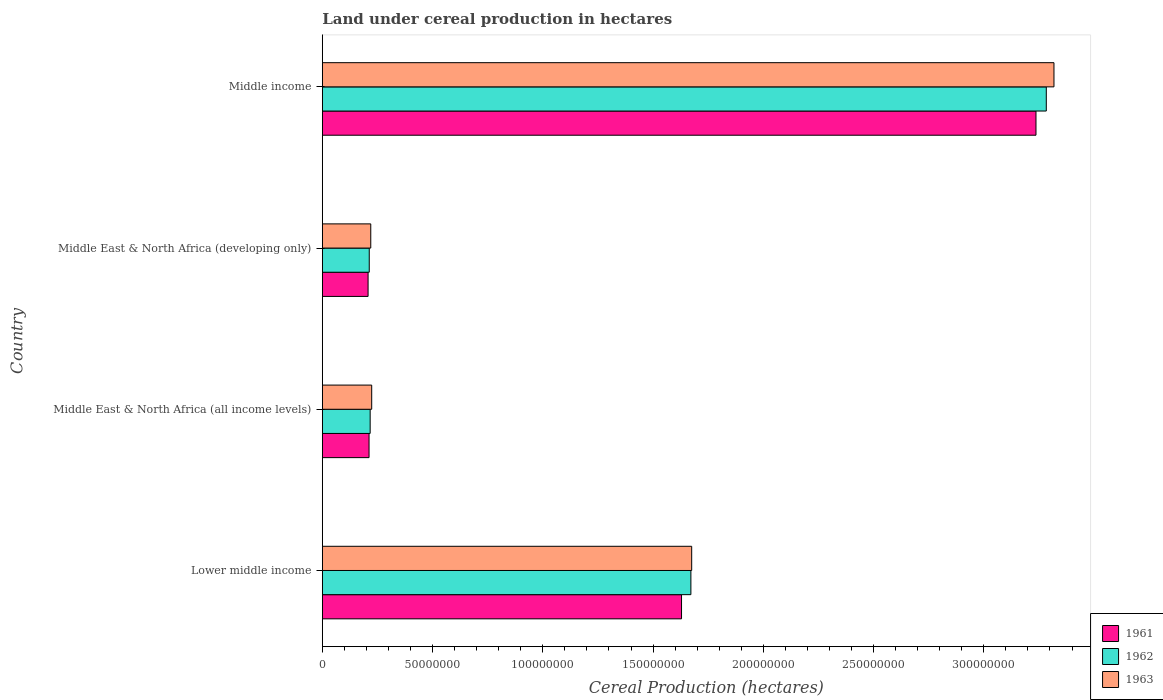How many different coloured bars are there?
Give a very brief answer. 3. How many groups of bars are there?
Ensure brevity in your answer.  4. Are the number of bars per tick equal to the number of legend labels?
Offer a very short reply. Yes. What is the label of the 2nd group of bars from the top?
Ensure brevity in your answer.  Middle East & North Africa (developing only). In how many cases, is the number of bars for a given country not equal to the number of legend labels?
Your answer should be very brief. 0. What is the land under cereal production in 1962 in Lower middle income?
Provide a short and direct response. 1.67e+08. Across all countries, what is the maximum land under cereal production in 1963?
Give a very brief answer. 3.32e+08. Across all countries, what is the minimum land under cereal production in 1963?
Your answer should be very brief. 2.20e+07. In which country was the land under cereal production in 1962 maximum?
Ensure brevity in your answer.  Middle income. In which country was the land under cereal production in 1962 minimum?
Offer a terse response. Middle East & North Africa (developing only). What is the total land under cereal production in 1963 in the graph?
Your answer should be very brief. 5.44e+08. What is the difference between the land under cereal production in 1963 in Lower middle income and that in Middle income?
Offer a very short reply. -1.64e+08. What is the difference between the land under cereal production in 1963 in Middle income and the land under cereal production in 1962 in Middle East & North Africa (developing only)?
Make the answer very short. 3.11e+08. What is the average land under cereal production in 1963 per country?
Make the answer very short. 1.36e+08. What is the difference between the land under cereal production in 1961 and land under cereal production in 1962 in Middle income?
Your answer should be very brief. -4.68e+06. In how many countries, is the land under cereal production in 1963 greater than 180000000 hectares?
Offer a very short reply. 1. What is the ratio of the land under cereal production in 1961 in Lower middle income to that in Middle East & North Africa (developing only)?
Make the answer very short. 7.85. Is the land under cereal production in 1961 in Middle East & North Africa (all income levels) less than that in Middle East & North Africa (developing only)?
Your response must be concise. No. Is the difference between the land under cereal production in 1961 in Middle East & North Africa (all income levels) and Middle East & North Africa (developing only) greater than the difference between the land under cereal production in 1962 in Middle East & North Africa (all income levels) and Middle East & North Africa (developing only)?
Provide a short and direct response. Yes. What is the difference between the highest and the second highest land under cereal production in 1963?
Provide a short and direct response. 1.64e+08. What is the difference between the highest and the lowest land under cereal production in 1963?
Your response must be concise. 3.10e+08. In how many countries, is the land under cereal production in 1961 greater than the average land under cereal production in 1961 taken over all countries?
Offer a very short reply. 2. Is the sum of the land under cereal production in 1961 in Middle East & North Africa (developing only) and Middle income greater than the maximum land under cereal production in 1963 across all countries?
Offer a terse response. Yes. What does the 1st bar from the top in Lower middle income represents?
Keep it short and to the point. 1963. How many bars are there?
Make the answer very short. 12. What is the difference between two consecutive major ticks on the X-axis?
Provide a succinct answer. 5.00e+07. Are the values on the major ticks of X-axis written in scientific E-notation?
Ensure brevity in your answer.  No. Does the graph contain any zero values?
Your answer should be compact. No. Does the graph contain grids?
Your answer should be compact. No. Where does the legend appear in the graph?
Ensure brevity in your answer.  Bottom right. What is the title of the graph?
Your answer should be compact. Land under cereal production in hectares. Does "2000" appear as one of the legend labels in the graph?
Provide a short and direct response. No. What is the label or title of the X-axis?
Offer a very short reply. Cereal Production (hectares). What is the Cereal Production (hectares) of 1961 in Lower middle income?
Offer a very short reply. 1.63e+08. What is the Cereal Production (hectares) of 1962 in Lower middle income?
Provide a short and direct response. 1.67e+08. What is the Cereal Production (hectares) of 1963 in Lower middle income?
Provide a short and direct response. 1.68e+08. What is the Cereal Production (hectares) of 1961 in Middle East & North Africa (all income levels)?
Your response must be concise. 2.12e+07. What is the Cereal Production (hectares) of 1962 in Middle East & North Africa (all income levels)?
Give a very brief answer. 2.17e+07. What is the Cereal Production (hectares) in 1963 in Middle East & North Africa (all income levels)?
Offer a terse response. 2.24e+07. What is the Cereal Production (hectares) of 1961 in Middle East & North Africa (developing only)?
Provide a short and direct response. 2.08e+07. What is the Cereal Production (hectares) of 1962 in Middle East & North Africa (developing only)?
Your answer should be compact. 2.13e+07. What is the Cereal Production (hectares) in 1963 in Middle East & North Africa (developing only)?
Your answer should be compact. 2.20e+07. What is the Cereal Production (hectares) in 1961 in Middle income?
Your response must be concise. 3.24e+08. What is the Cereal Production (hectares) of 1962 in Middle income?
Make the answer very short. 3.28e+08. What is the Cereal Production (hectares) of 1963 in Middle income?
Give a very brief answer. 3.32e+08. Across all countries, what is the maximum Cereal Production (hectares) in 1961?
Your answer should be compact. 3.24e+08. Across all countries, what is the maximum Cereal Production (hectares) of 1962?
Make the answer very short. 3.28e+08. Across all countries, what is the maximum Cereal Production (hectares) in 1963?
Your answer should be very brief. 3.32e+08. Across all countries, what is the minimum Cereal Production (hectares) of 1961?
Give a very brief answer. 2.08e+07. Across all countries, what is the minimum Cereal Production (hectares) in 1962?
Give a very brief answer. 2.13e+07. Across all countries, what is the minimum Cereal Production (hectares) of 1963?
Make the answer very short. 2.20e+07. What is the total Cereal Production (hectares) of 1961 in the graph?
Ensure brevity in your answer.  5.28e+08. What is the total Cereal Production (hectares) in 1962 in the graph?
Your response must be concise. 5.38e+08. What is the total Cereal Production (hectares) of 1963 in the graph?
Keep it short and to the point. 5.44e+08. What is the difference between the Cereal Production (hectares) in 1961 in Lower middle income and that in Middle East & North Africa (all income levels)?
Keep it short and to the point. 1.42e+08. What is the difference between the Cereal Production (hectares) of 1962 in Lower middle income and that in Middle East & North Africa (all income levels)?
Offer a terse response. 1.45e+08. What is the difference between the Cereal Production (hectares) in 1963 in Lower middle income and that in Middle East & North Africa (all income levels)?
Keep it short and to the point. 1.45e+08. What is the difference between the Cereal Production (hectares) in 1961 in Lower middle income and that in Middle East & North Africa (developing only)?
Make the answer very short. 1.42e+08. What is the difference between the Cereal Production (hectares) in 1962 in Lower middle income and that in Middle East & North Africa (developing only)?
Offer a very short reply. 1.46e+08. What is the difference between the Cereal Production (hectares) of 1963 in Lower middle income and that in Middle East & North Africa (developing only)?
Your answer should be compact. 1.46e+08. What is the difference between the Cereal Production (hectares) of 1961 in Lower middle income and that in Middle income?
Ensure brevity in your answer.  -1.61e+08. What is the difference between the Cereal Production (hectares) in 1962 in Lower middle income and that in Middle income?
Make the answer very short. -1.61e+08. What is the difference between the Cereal Production (hectares) of 1963 in Lower middle income and that in Middle income?
Keep it short and to the point. -1.64e+08. What is the difference between the Cereal Production (hectares) in 1961 in Middle East & North Africa (all income levels) and that in Middle East & North Africa (developing only)?
Provide a short and direct response. 4.35e+05. What is the difference between the Cereal Production (hectares) in 1962 in Middle East & North Africa (all income levels) and that in Middle East & North Africa (developing only)?
Keep it short and to the point. 4.12e+05. What is the difference between the Cereal Production (hectares) in 1963 in Middle East & North Africa (all income levels) and that in Middle East & North Africa (developing only)?
Provide a succinct answer. 4.25e+05. What is the difference between the Cereal Production (hectares) in 1961 in Middle East & North Africa (all income levels) and that in Middle income?
Offer a terse response. -3.02e+08. What is the difference between the Cereal Production (hectares) in 1962 in Middle East & North Africa (all income levels) and that in Middle income?
Make the answer very short. -3.07e+08. What is the difference between the Cereal Production (hectares) of 1963 in Middle East & North Africa (all income levels) and that in Middle income?
Make the answer very short. -3.09e+08. What is the difference between the Cereal Production (hectares) of 1961 in Middle East & North Africa (developing only) and that in Middle income?
Your answer should be very brief. -3.03e+08. What is the difference between the Cereal Production (hectares) in 1962 in Middle East & North Africa (developing only) and that in Middle income?
Ensure brevity in your answer.  -3.07e+08. What is the difference between the Cereal Production (hectares) in 1963 in Middle East & North Africa (developing only) and that in Middle income?
Your answer should be very brief. -3.10e+08. What is the difference between the Cereal Production (hectares) in 1961 in Lower middle income and the Cereal Production (hectares) in 1962 in Middle East & North Africa (all income levels)?
Provide a short and direct response. 1.41e+08. What is the difference between the Cereal Production (hectares) of 1961 in Lower middle income and the Cereal Production (hectares) of 1963 in Middle East & North Africa (all income levels)?
Give a very brief answer. 1.41e+08. What is the difference between the Cereal Production (hectares) in 1962 in Lower middle income and the Cereal Production (hectares) in 1963 in Middle East & North Africa (all income levels)?
Give a very brief answer. 1.45e+08. What is the difference between the Cereal Production (hectares) of 1961 in Lower middle income and the Cereal Production (hectares) of 1962 in Middle East & North Africa (developing only)?
Make the answer very short. 1.42e+08. What is the difference between the Cereal Production (hectares) of 1961 in Lower middle income and the Cereal Production (hectares) of 1963 in Middle East & North Africa (developing only)?
Ensure brevity in your answer.  1.41e+08. What is the difference between the Cereal Production (hectares) of 1962 in Lower middle income and the Cereal Production (hectares) of 1963 in Middle East & North Africa (developing only)?
Ensure brevity in your answer.  1.45e+08. What is the difference between the Cereal Production (hectares) of 1961 in Lower middle income and the Cereal Production (hectares) of 1962 in Middle income?
Ensure brevity in your answer.  -1.65e+08. What is the difference between the Cereal Production (hectares) of 1961 in Lower middle income and the Cereal Production (hectares) of 1963 in Middle income?
Provide a short and direct response. -1.69e+08. What is the difference between the Cereal Production (hectares) in 1962 in Lower middle income and the Cereal Production (hectares) in 1963 in Middle income?
Provide a short and direct response. -1.65e+08. What is the difference between the Cereal Production (hectares) of 1961 in Middle East & North Africa (all income levels) and the Cereal Production (hectares) of 1962 in Middle East & North Africa (developing only)?
Keep it short and to the point. -9.45e+04. What is the difference between the Cereal Production (hectares) of 1961 in Middle East & North Africa (all income levels) and the Cereal Production (hectares) of 1963 in Middle East & North Africa (developing only)?
Provide a short and direct response. -7.81e+05. What is the difference between the Cereal Production (hectares) of 1962 in Middle East & North Africa (all income levels) and the Cereal Production (hectares) of 1963 in Middle East & North Africa (developing only)?
Your response must be concise. -2.75e+05. What is the difference between the Cereal Production (hectares) in 1961 in Middle East & North Africa (all income levels) and the Cereal Production (hectares) in 1962 in Middle income?
Offer a very short reply. -3.07e+08. What is the difference between the Cereal Production (hectares) in 1961 in Middle East & North Africa (all income levels) and the Cereal Production (hectares) in 1963 in Middle income?
Provide a short and direct response. -3.11e+08. What is the difference between the Cereal Production (hectares) of 1962 in Middle East & North Africa (all income levels) and the Cereal Production (hectares) of 1963 in Middle income?
Keep it short and to the point. -3.10e+08. What is the difference between the Cereal Production (hectares) in 1961 in Middle East & North Africa (developing only) and the Cereal Production (hectares) in 1962 in Middle income?
Give a very brief answer. -3.08e+08. What is the difference between the Cereal Production (hectares) in 1961 in Middle East & North Africa (developing only) and the Cereal Production (hectares) in 1963 in Middle income?
Give a very brief answer. -3.11e+08. What is the difference between the Cereal Production (hectares) of 1962 in Middle East & North Africa (developing only) and the Cereal Production (hectares) of 1963 in Middle income?
Offer a terse response. -3.11e+08. What is the average Cereal Production (hectares) of 1961 per country?
Give a very brief answer. 1.32e+08. What is the average Cereal Production (hectares) in 1962 per country?
Make the answer very short. 1.35e+08. What is the average Cereal Production (hectares) in 1963 per country?
Provide a short and direct response. 1.36e+08. What is the difference between the Cereal Production (hectares) in 1961 and Cereal Production (hectares) in 1962 in Lower middle income?
Offer a terse response. -4.24e+06. What is the difference between the Cereal Production (hectares) of 1961 and Cereal Production (hectares) of 1963 in Lower middle income?
Keep it short and to the point. -4.60e+06. What is the difference between the Cereal Production (hectares) of 1962 and Cereal Production (hectares) of 1963 in Lower middle income?
Provide a succinct answer. -3.61e+05. What is the difference between the Cereal Production (hectares) of 1961 and Cereal Production (hectares) of 1962 in Middle East & North Africa (all income levels)?
Your answer should be very brief. -5.06e+05. What is the difference between the Cereal Production (hectares) of 1961 and Cereal Production (hectares) of 1963 in Middle East & North Africa (all income levels)?
Give a very brief answer. -1.21e+06. What is the difference between the Cereal Production (hectares) in 1962 and Cereal Production (hectares) in 1963 in Middle East & North Africa (all income levels)?
Your answer should be compact. -7.00e+05. What is the difference between the Cereal Production (hectares) in 1961 and Cereal Production (hectares) in 1962 in Middle East & North Africa (developing only)?
Ensure brevity in your answer.  -5.29e+05. What is the difference between the Cereal Production (hectares) of 1961 and Cereal Production (hectares) of 1963 in Middle East & North Africa (developing only)?
Keep it short and to the point. -1.22e+06. What is the difference between the Cereal Production (hectares) of 1962 and Cereal Production (hectares) of 1963 in Middle East & North Africa (developing only)?
Give a very brief answer. -6.86e+05. What is the difference between the Cereal Production (hectares) of 1961 and Cereal Production (hectares) of 1962 in Middle income?
Ensure brevity in your answer.  -4.68e+06. What is the difference between the Cereal Production (hectares) in 1961 and Cereal Production (hectares) in 1963 in Middle income?
Make the answer very short. -8.16e+06. What is the difference between the Cereal Production (hectares) of 1962 and Cereal Production (hectares) of 1963 in Middle income?
Provide a succinct answer. -3.48e+06. What is the ratio of the Cereal Production (hectares) of 1961 in Lower middle income to that in Middle East & North Africa (all income levels)?
Provide a short and direct response. 7.69. What is the ratio of the Cereal Production (hectares) of 1962 in Lower middle income to that in Middle East & North Africa (all income levels)?
Keep it short and to the point. 7.71. What is the ratio of the Cereal Production (hectares) of 1963 in Lower middle income to that in Middle East & North Africa (all income levels)?
Keep it short and to the point. 7.48. What is the ratio of the Cereal Production (hectares) of 1961 in Lower middle income to that in Middle East & North Africa (developing only)?
Make the answer very short. 7.85. What is the ratio of the Cereal Production (hectares) in 1962 in Lower middle income to that in Middle East & North Africa (developing only)?
Offer a very short reply. 7.85. What is the ratio of the Cereal Production (hectares) of 1963 in Lower middle income to that in Middle East & North Africa (developing only)?
Your response must be concise. 7.63. What is the ratio of the Cereal Production (hectares) in 1961 in Lower middle income to that in Middle income?
Give a very brief answer. 0.5. What is the ratio of the Cereal Production (hectares) of 1962 in Lower middle income to that in Middle income?
Make the answer very short. 0.51. What is the ratio of the Cereal Production (hectares) in 1963 in Lower middle income to that in Middle income?
Provide a succinct answer. 0.5. What is the ratio of the Cereal Production (hectares) in 1961 in Middle East & North Africa (all income levels) to that in Middle East & North Africa (developing only)?
Make the answer very short. 1.02. What is the ratio of the Cereal Production (hectares) in 1962 in Middle East & North Africa (all income levels) to that in Middle East & North Africa (developing only)?
Provide a succinct answer. 1.02. What is the ratio of the Cereal Production (hectares) in 1963 in Middle East & North Africa (all income levels) to that in Middle East & North Africa (developing only)?
Offer a very short reply. 1.02. What is the ratio of the Cereal Production (hectares) of 1961 in Middle East & North Africa (all income levels) to that in Middle income?
Provide a succinct answer. 0.07. What is the ratio of the Cereal Production (hectares) in 1962 in Middle East & North Africa (all income levels) to that in Middle income?
Offer a terse response. 0.07. What is the ratio of the Cereal Production (hectares) in 1963 in Middle East & North Africa (all income levels) to that in Middle income?
Keep it short and to the point. 0.07. What is the ratio of the Cereal Production (hectares) in 1961 in Middle East & North Africa (developing only) to that in Middle income?
Provide a short and direct response. 0.06. What is the ratio of the Cereal Production (hectares) in 1962 in Middle East & North Africa (developing only) to that in Middle income?
Ensure brevity in your answer.  0.06. What is the ratio of the Cereal Production (hectares) of 1963 in Middle East & North Africa (developing only) to that in Middle income?
Keep it short and to the point. 0.07. What is the difference between the highest and the second highest Cereal Production (hectares) in 1961?
Give a very brief answer. 1.61e+08. What is the difference between the highest and the second highest Cereal Production (hectares) in 1962?
Ensure brevity in your answer.  1.61e+08. What is the difference between the highest and the second highest Cereal Production (hectares) of 1963?
Ensure brevity in your answer.  1.64e+08. What is the difference between the highest and the lowest Cereal Production (hectares) in 1961?
Provide a succinct answer. 3.03e+08. What is the difference between the highest and the lowest Cereal Production (hectares) in 1962?
Give a very brief answer. 3.07e+08. What is the difference between the highest and the lowest Cereal Production (hectares) of 1963?
Offer a terse response. 3.10e+08. 